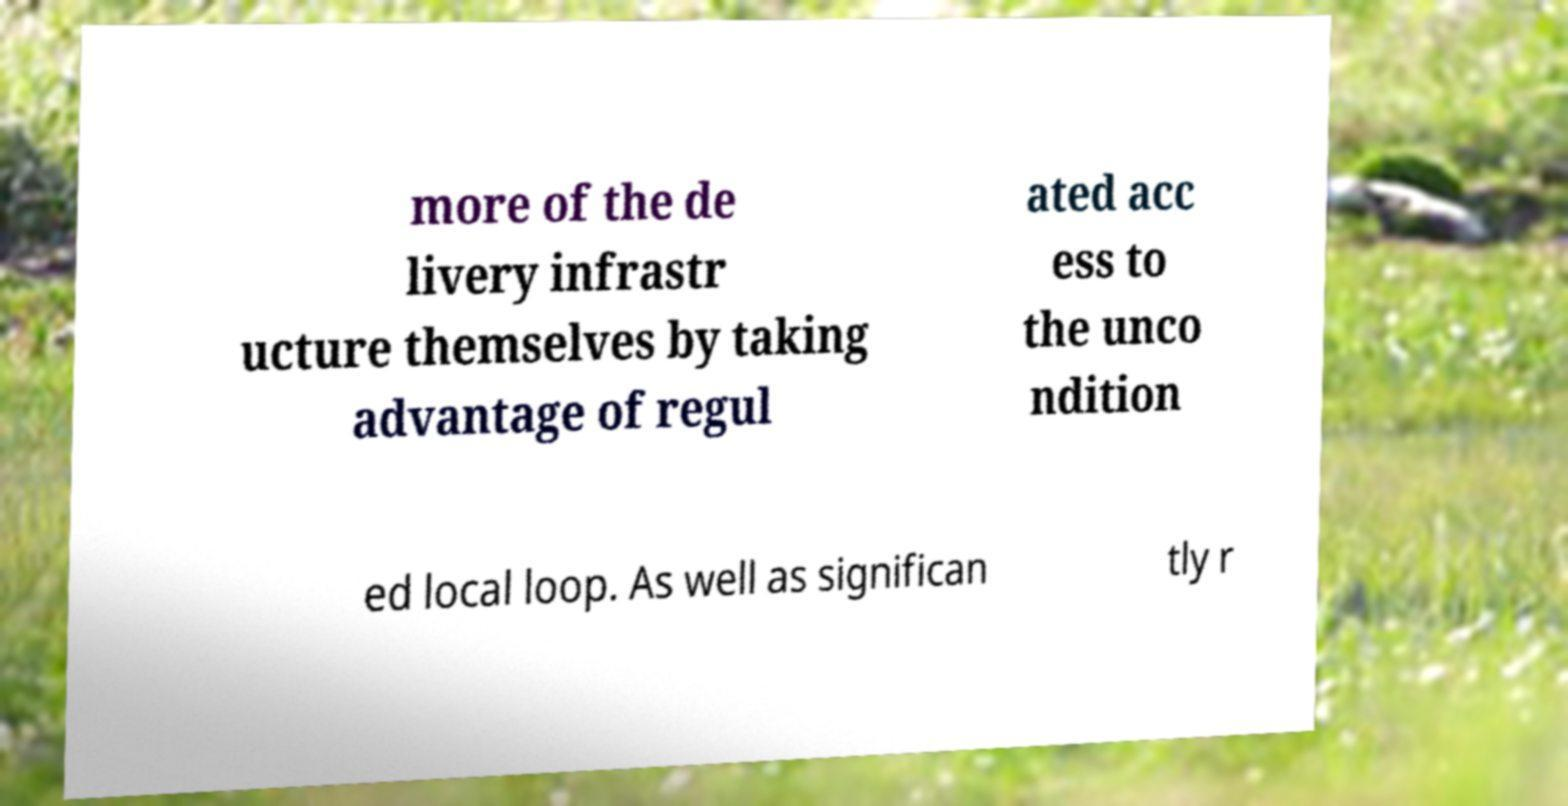There's text embedded in this image that I need extracted. Can you transcribe it verbatim? more of the de livery infrastr ucture themselves by taking advantage of regul ated acc ess to the unco ndition ed local loop. As well as significan tly r 